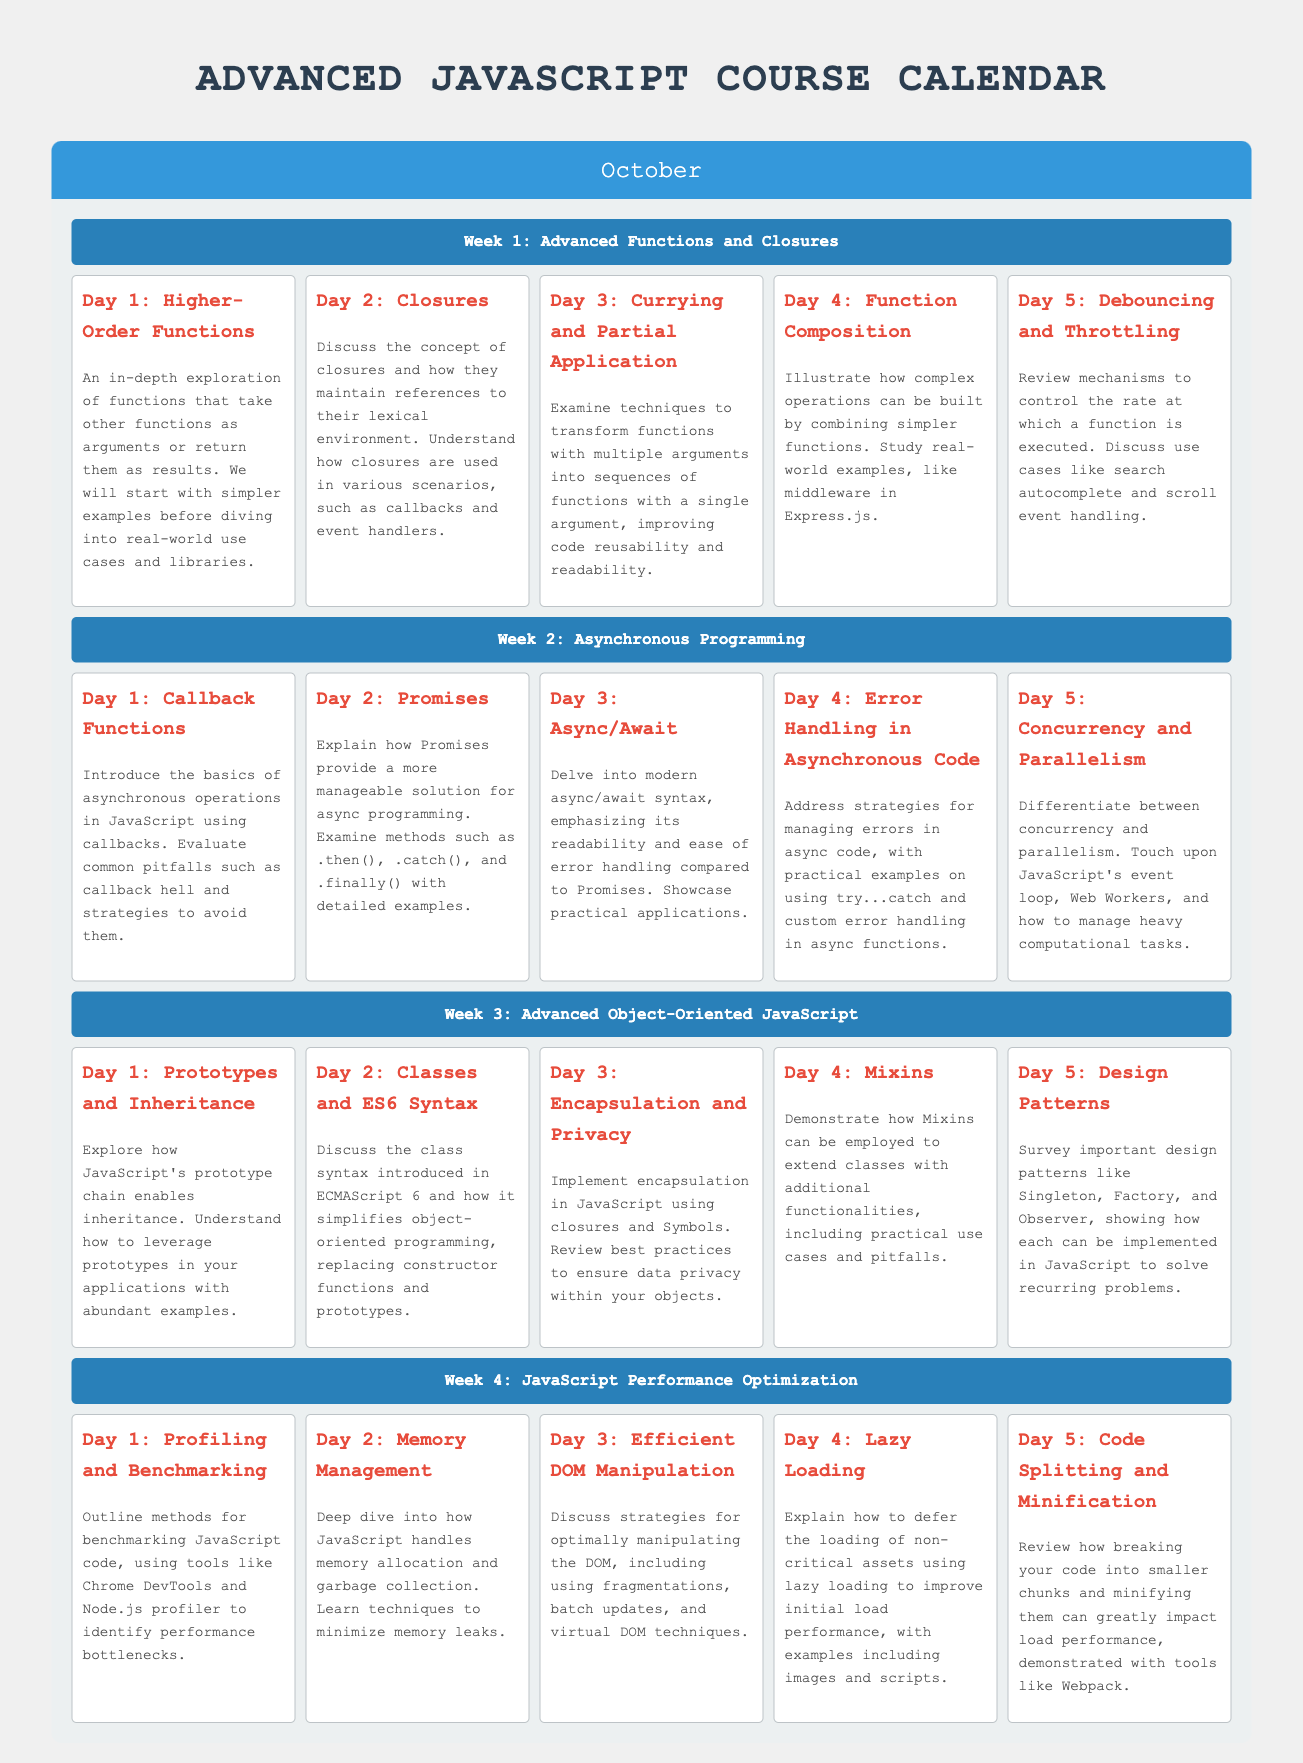What is the title of the course? The document identifies the title clearly at the top as "Advanced JavaScript Course Calendar."
Answer: Advanced JavaScript Course Calendar How many weeks are in the October curriculum? The document outlines four distinct weeks that are clearly specified.
Answer: 4 What is covered in Week 2? The calendar specifies that Week 2 focuses on "Asynchronous Programming."
Answer: Asynchronous Programming Name one topic discussed in Week 1. Week 1 features several topics, one of which is "Higher-Order Functions."
Answer: Higher-Order Functions What technique is examined on Day 3 of Week 1? The document explicitly states that Day 3 discusses "Currying and Partial Application."
Answer: Currying and Partial Application How is error handling addressed in the course? In Week 2, Day 4, the document mentions strategies for managing errors in asynchronous code.
Answer: Error Handling in Asynchronous Code What is one method discussed for performance optimization? The document provides examples of performance optimization methods such as "Profiling and Benchmarking."
Answer: Profiling and Benchmarking What design pattern is covered on Day 5 of Week 3? The curriculum states that "Observer" is one of the design patterns studied on this day.
Answer: Observer What is a subject addressed in Week 4? The document specifies that Week 4 is focused on "JavaScript Performance Optimization."
Answer: JavaScript Performance Optimization 